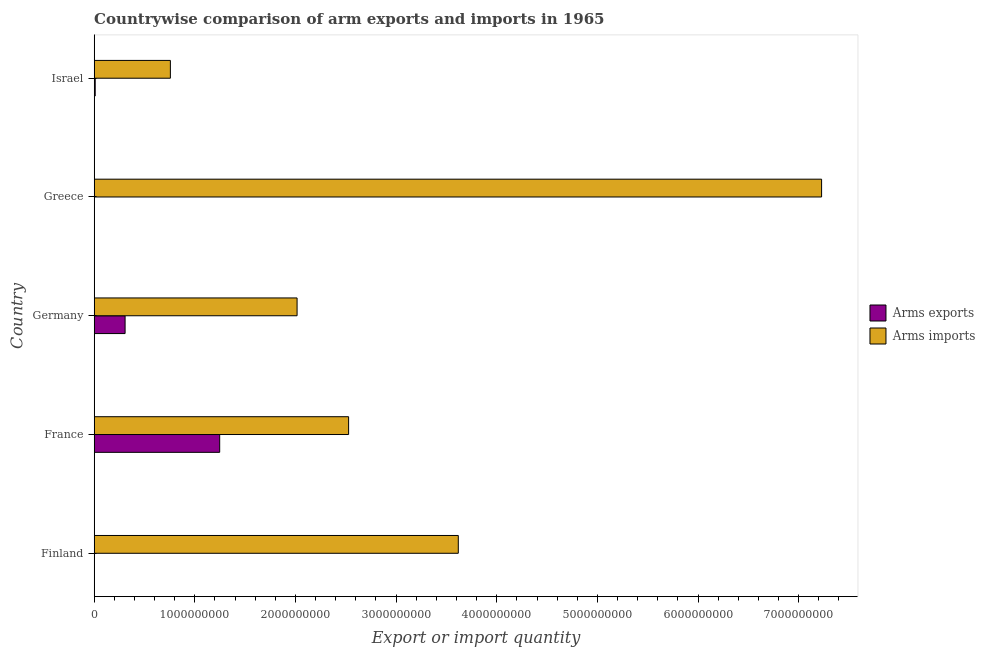How many groups of bars are there?
Keep it short and to the point. 5. Are the number of bars per tick equal to the number of legend labels?
Ensure brevity in your answer.  Yes. What is the label of the 5th group of bars from the top?
Give a very brief answer. Finland. In how many cases, is the number of bars for a given country not equal to the number of legend labels?
Ensure brevity in your answer.  0. What is the arms exports in Germany?
Give a very brief answer. 3.07e+08. Across all countries, what is the maximum arms exports?
Your response must be concise. 1.25e+09. Across all countries, what is the minimum arms exports?
Keep it short and to the point. 1.00e+06. In which country was the arms exports maximum?
Make the answer very short. France. What is the total arms exports in the graph?
Your answer should be compact. 1.57e+09. What is the difference between the arms exports in France and that in Greece?
Offer a very short reply. 1.25e+09. What is the difference between the arms exports in Israel and the arms imports in France?
Offer a very short reply. -2.52e+09. What is the average arms exports per country?
Provide a succinct answer. 3.13e+08. What is the difference between the arms imports and arms exports in Greece?
Your response must be concise. 7.23e+09. In how many countries, is the arms imports greater than 200000000 ?
Make the answer very short. 5. What is the ratio of the arms imports in Greece to that in Israel?
Give a very brief answer. 9.55. Is the arms exports in Finland less than that in Germany?
Your response must be concise. Yes. Is the difference between the arms exports in Germany and Greece greater than the difference between the arms imports in Germany and Greece?
Give a very brief answer. Yes. What is the difference between the highest and the second highest arms exports?
Ensure brevity in your answer.  9.40e+08. What is the difference between the highest and the lowest arms imports?
Your answer should be compact. 6.47e+09. In how many countries, is the arms imports greater than the average arms imports taken over all countries?
Your response must be concise. 2. Is the sum of the arms imports in France and Greece greater than the maximum arms exports across all countries?
Make the answer very short. Yes. What does the 1st bar from the top in Greece represents?
Ensure brevity in your answer.  Arms imports. What does the 1st bar from the bottom in Finland represents?
Make the answer very short. Arms exports. How many bars are there?
Your response must be concise. 10. Are all the bars in the graph horizontal?
Provide a short and direct response. Yes. What is the difference between two consecutive major ticks on the X-axis?
Offer a terse response. 1.00e+09. How are the legend labels stacked?
Keep it short and to the point. Vertical. What is the title of the graph?
Give a very brief answer. Countrywise comparison of arm exports and imports in 1965. Does "From World Bank" appear as one of the legend labels in the graph?
Keep it short and to the point. No. What is the label or title of the X-axis?
Offer a very short reply. Export or import quantity. What is the label or title of the Y-axis?
Ensure brevity in your answer.  Country. What is the Export or import quantity of Arms imports in Finland?
Make the answer very short. 3.62e+09. What is the Export or import quantity in Arms exports in France?
Ensure brevity in your answer.  1.25e+09. What is the Export or import quantity in Arms imports in France?
Make the answer very short. 2.53e+09. What is the Export or import quantity in Arms exports in Germany?
Your answer should be compact. 3.07e+08. What is the Export or import quantity in Arms imports in Germany?
Make the answer very short. 2.02e+09. What is the Export or import quantity in Arms imports in Greece?
Provide a succinct answer. 7.23e+09. What is the Export or import quantity of Arms exports in Israel?
Offer a very short reply. 1.00e+07. What is the Export or import quantity in Arms imports in Israel?
Keep it short and to the point. 7.57e+08. Across all countries, what is the maximum Export or import quantity in Arms exports?
Provide a succinct answer. 1.25e+09. Across all countries, what is the maximum Export or import quantity in Arms imports?
Provide a short and direct response. 7.23e+09. Across all countries, what is the minimum Export or import quantity of Arms imports?
Provide a succinct answer. 7.57e+08. What is the total Export or import quantity in Arms exports in the graph?
Give a very brief answer. 1.57e+09. What is the total Export or import quantity of Arms imports in the graph?
Give a very brief answer. 1.61e+1. What is the difference between the Export or import quantity in Arms exports in Finland and that in France?
Offer a very short reply. -1.25e+09. What is the difference between the Export or import quantity in Arms imports in Finland and that in France?
Give a very brief answer. 1.09e+09. What is the difference between the Export or import quantity in Arms exports in Finland and that in Germany?
Provide a succinct answer. -3.06e+08. What is the difference between the Export or import quantity in Arms imports in Finland and that in Germany?
Keep it short and to the point. 1.60e+09. What is the difference between the Export or import quantity of Arms exports in Finland and that in Greece?
Offer a very short reply. 0. What is the difference between the Export or import quantity of Arms imports in Finland and that in Greece?
Give a very brief answer. -3.61e+09. What is the difference between the Export or import quantity in Arms exports in Finland and that in Israel?
Make the answer very short. -9.00e+06. What is the difference between the Export or import quantity in Arms imports in Finland and that in Israel?
Make the answer very short. 2.86e+09. What is the difference between the Export or import quantity of Arms exports in France and that in Germany?
Keep it short and to the point. 9.40e+08. What is the difference between the Export or import quantity of Arms imports in France and that in Germany?
Make the answer very short. 5.12e+08. What is the difference between the Export or import quantity in Arms exports in France and that in Greece?
Ensure brevity in your answer.  1.25e+09. What is the difference between the Export or import quantity in Arms imports in France and that in Greece?
Keep it short and to the point. -4.70e+09. What is the difference between the Export or import quantity of Arms exports in France and that in Israel?
Your answer should be very brief. 1.24e+09. What is the difference between the Export or import quantity in Arms imports in France and that in Israel?
Offer a terse response. 1.77e+09. What is the difference between the Export or import quantity of Arms exports in Germany and that in Greece?
Keep it short and to the point. 3.06e+08. What is the difference between the Export or import quantity in Arms imports in Germany and that in Greece?
Ensure brevity in your answer.  -5.21e+09. What is the difference between the Export or import quantity of Arms exports in Germany and that in Israel?
Provide a short and direct response. 2.97e+08. What is the difference between the Export or import quantity of Arms imports in Germany and that in Israel?
Give a very brief answer. 1.26e+09. What is the difference between the Export or import quantity of Arms exports in Greece and that in Israel?
Provide a short and direct response. -9.00e+06. What is the difference between the Export or import quantity in Arms imports in Greece and that in Israel?
Ensure brevity in your answer.  6.47e+09. What is the difference between the Export or import quantity in Arms exports in Finland and the Export or import quantity in Arms imports in France?
Your response must be concise. -2.53e+09. What is the difference between the Export or import quantity in Arms exports in Finland and the Export or import quantity in Arms imports in Germany?
Offer a terse response. -2.02e+09. What is the difference between the Export or import quantity in Arms exports in Finland and the Export or import quantity in Arms imports in Greece?
Your answer should be compact. -7.23e+09. What is the difference between the Export or import quantity of Arms exports in Finland and the Export or import quantity of Arms imports in Israel?
Provide a succinct answer. -7.56e+08. What is the difference between the Export or import quantity of Arms exports in France and the Export or import quantity of Arms imports in Germany?
Offer a very short reply. -7.69e+08. What is the difference between the Export or import quantity of Arms exports in France and the Export or import quantity of Arms imports in Greece?
Your answer should be very brief. -5.98e+09. What is the difference between the Export or import quantity in Arms exports in France and the Export or import quantity in Arms imports in Israel?
Give a very brief answer. 4.90e+08. What is the difference between the Export or import quantity of Arms exports in Germany and the Export or import quantity of Arms imports in Greece?
Offer a terse response. -6.92e+09. What is the difference between the Export or import quantity in Arms exports in Germany and the Export or import quantity in Arms imports in Israel?
Offer a very short reply. -4.50e+08. What is the difference between the Export or import quantity of Arms exports in Greece and the Export or import quantity of Arms imports in Israel?
Provide a succinct answer. -7.56e+08. What is the average Export or import quantity of Arms exports per country?
Ensure brevity in your answer.  3.13e+08. What is the average Export or import quantity in Arms imports per country?
Provide a succinct answer. 3.23e+09. What is the difference between the Export or import quantity of Arms exports and Export or import quantity of Arms imports in Finland?
Ensure brevity in your answer.  -3.62e+09. What is the difference between the Export or import quantity in Arms exports and Export or import quantity in Arms imports in France?
Your answer should be compact. -1.28e+09. What is the difference between the Export or import quantity in Arms exports and Export or import quantity in Arms imports in Germany?
Keep it short and to the point. -1.71e+09. What is the difference between the Export or import quantity in Arms exports and Export or import quantity in Arms imports in Greece?
Offer a terse response. -7.23e+09. What is the difference between the Export or import quantity in Arms exports and Export or import quantity in Arms imports in Israel?
Offer a very short reply. -7.47e+08. What is the ratio of the Export or import quantity in Arms exports in Finland to that in France?
Provide a short and direct response. 0. What is the ratio of the Export or import quantity in Arms imports in Finland to that in France?
Ensure brevity in your answer.  1.43. What is the ratio of the Export or import quantity in Arms exports in Finland to that in Germany?
Provide a short and direct response. 0. What is the ratio of the Export or import quantity of Arms imports in Finland to that in Germany?
Your answer should be very brief. 1.79. What is the ratio of the Export or import quantity in Arms exports in Finland to that in Greece?
Your response must be concise. 1. What is the ratio of the Export or import quantity of Arms imports in Finland to that in Greece?
Offer a terse response. 0.5. What is the ratio of the Export or import quantity in Arms imports in Finland to that in Israel?
Your answer should be compact. 4.78. What is the ratio of the Export or import quantity in Arms exports in France to that in Germany?
Your answer should be compact. 4.06. What is the ratio of the Export or import quantity in Arms imports in France to that in Germany?
Offer a terse response. 1.25. What is the ratio of the Export or import quantity in Arms exports in France to that in Greece?
Give a very brief answer. 1247. What is the ratio of the Export or import quantity in Arms imports in France to that in Greece?
Ensure brevity in your answer.  0.35. What is the ratio of the Export or import quantity in Arms exports in France to that in Israel?
Offer a very short reply. 124.7. What is the ratio of the Export or import quantity in Arms imports in France to that in Israel?
Your answer should be compact. 3.34. What is the ratio of the Export or import quantity of Arms exports in Germany to that in Greece?
Offer a terse response. 307. What is the ratio of the Export or import quantity in Arms imports in Germany to that in Greece?
Your response must be concise. 0.28. What is the ratio of the Export or import quantity of Arms exports in Germany to that in Israel?
Make the answer very short. 30.7. What is the ratio of the Export or import quantity in Arms imports in Germany to that in Israel?
Keep it short and to the point. 2.66. What is the ratio of the Export or import quantity of Arms imports in Greece to that in Israel?
Ensure brevity in your answer.  9.55. What is the difference between the highest and the second highest Export or import quantity in Arms exports?
Offer a terse response. 9.40e+08. What is the difference between the highest and the second highest Export or import quantity of Arms imports?
Make the answer very short. 3.61e+09. What is the difference between the highest and the lowest Export or import quantity of Arms exports?
Provide a succinct answer. 1.25e+09. What is the difference between the highest and the lowest Export or import quantity in Arms imports?
Make the answer very short. 6.47e+09. 